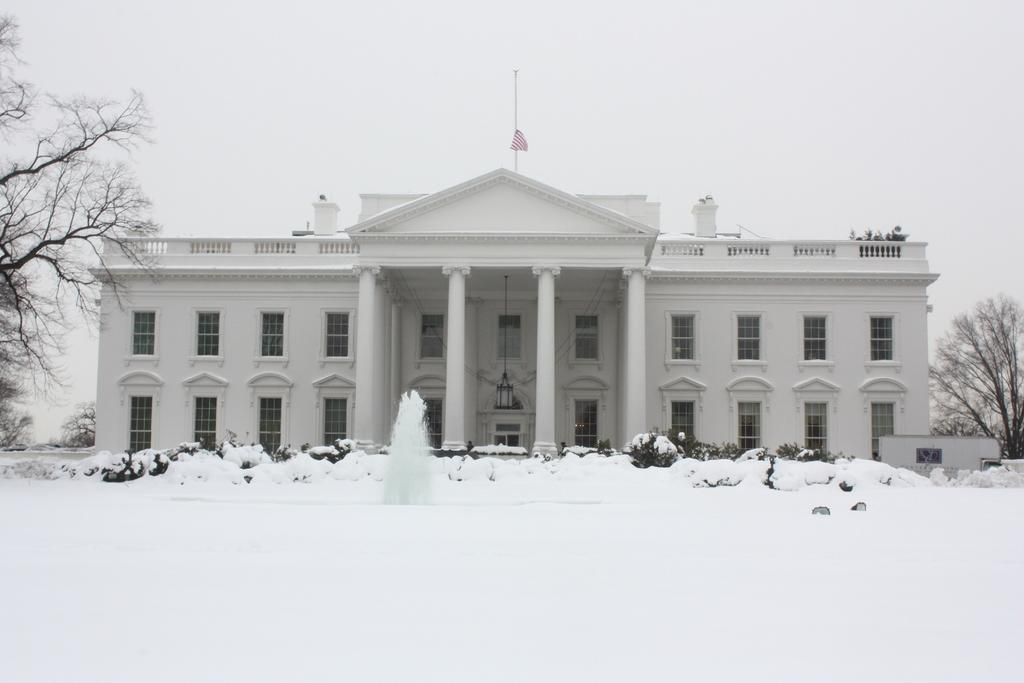What type of vegetation can be seen in the image? There are trees in the image. What is the weather like in the image? There is snow in the image, indicating a cold or wintery environment. What is the flag attached to in the image? The flag is attached to a pole or structure in the image. What type of structure is visible in the image? There is a building with windows in the image. What is visible in the background of the image? The sky is visible in the background of the image. How many moms are present in the image? There is no mention of a mom or any people in the image. What type of tray is being used to serve the snow in the image? There is no tray present in the image; the snow is on the ground or trees. 